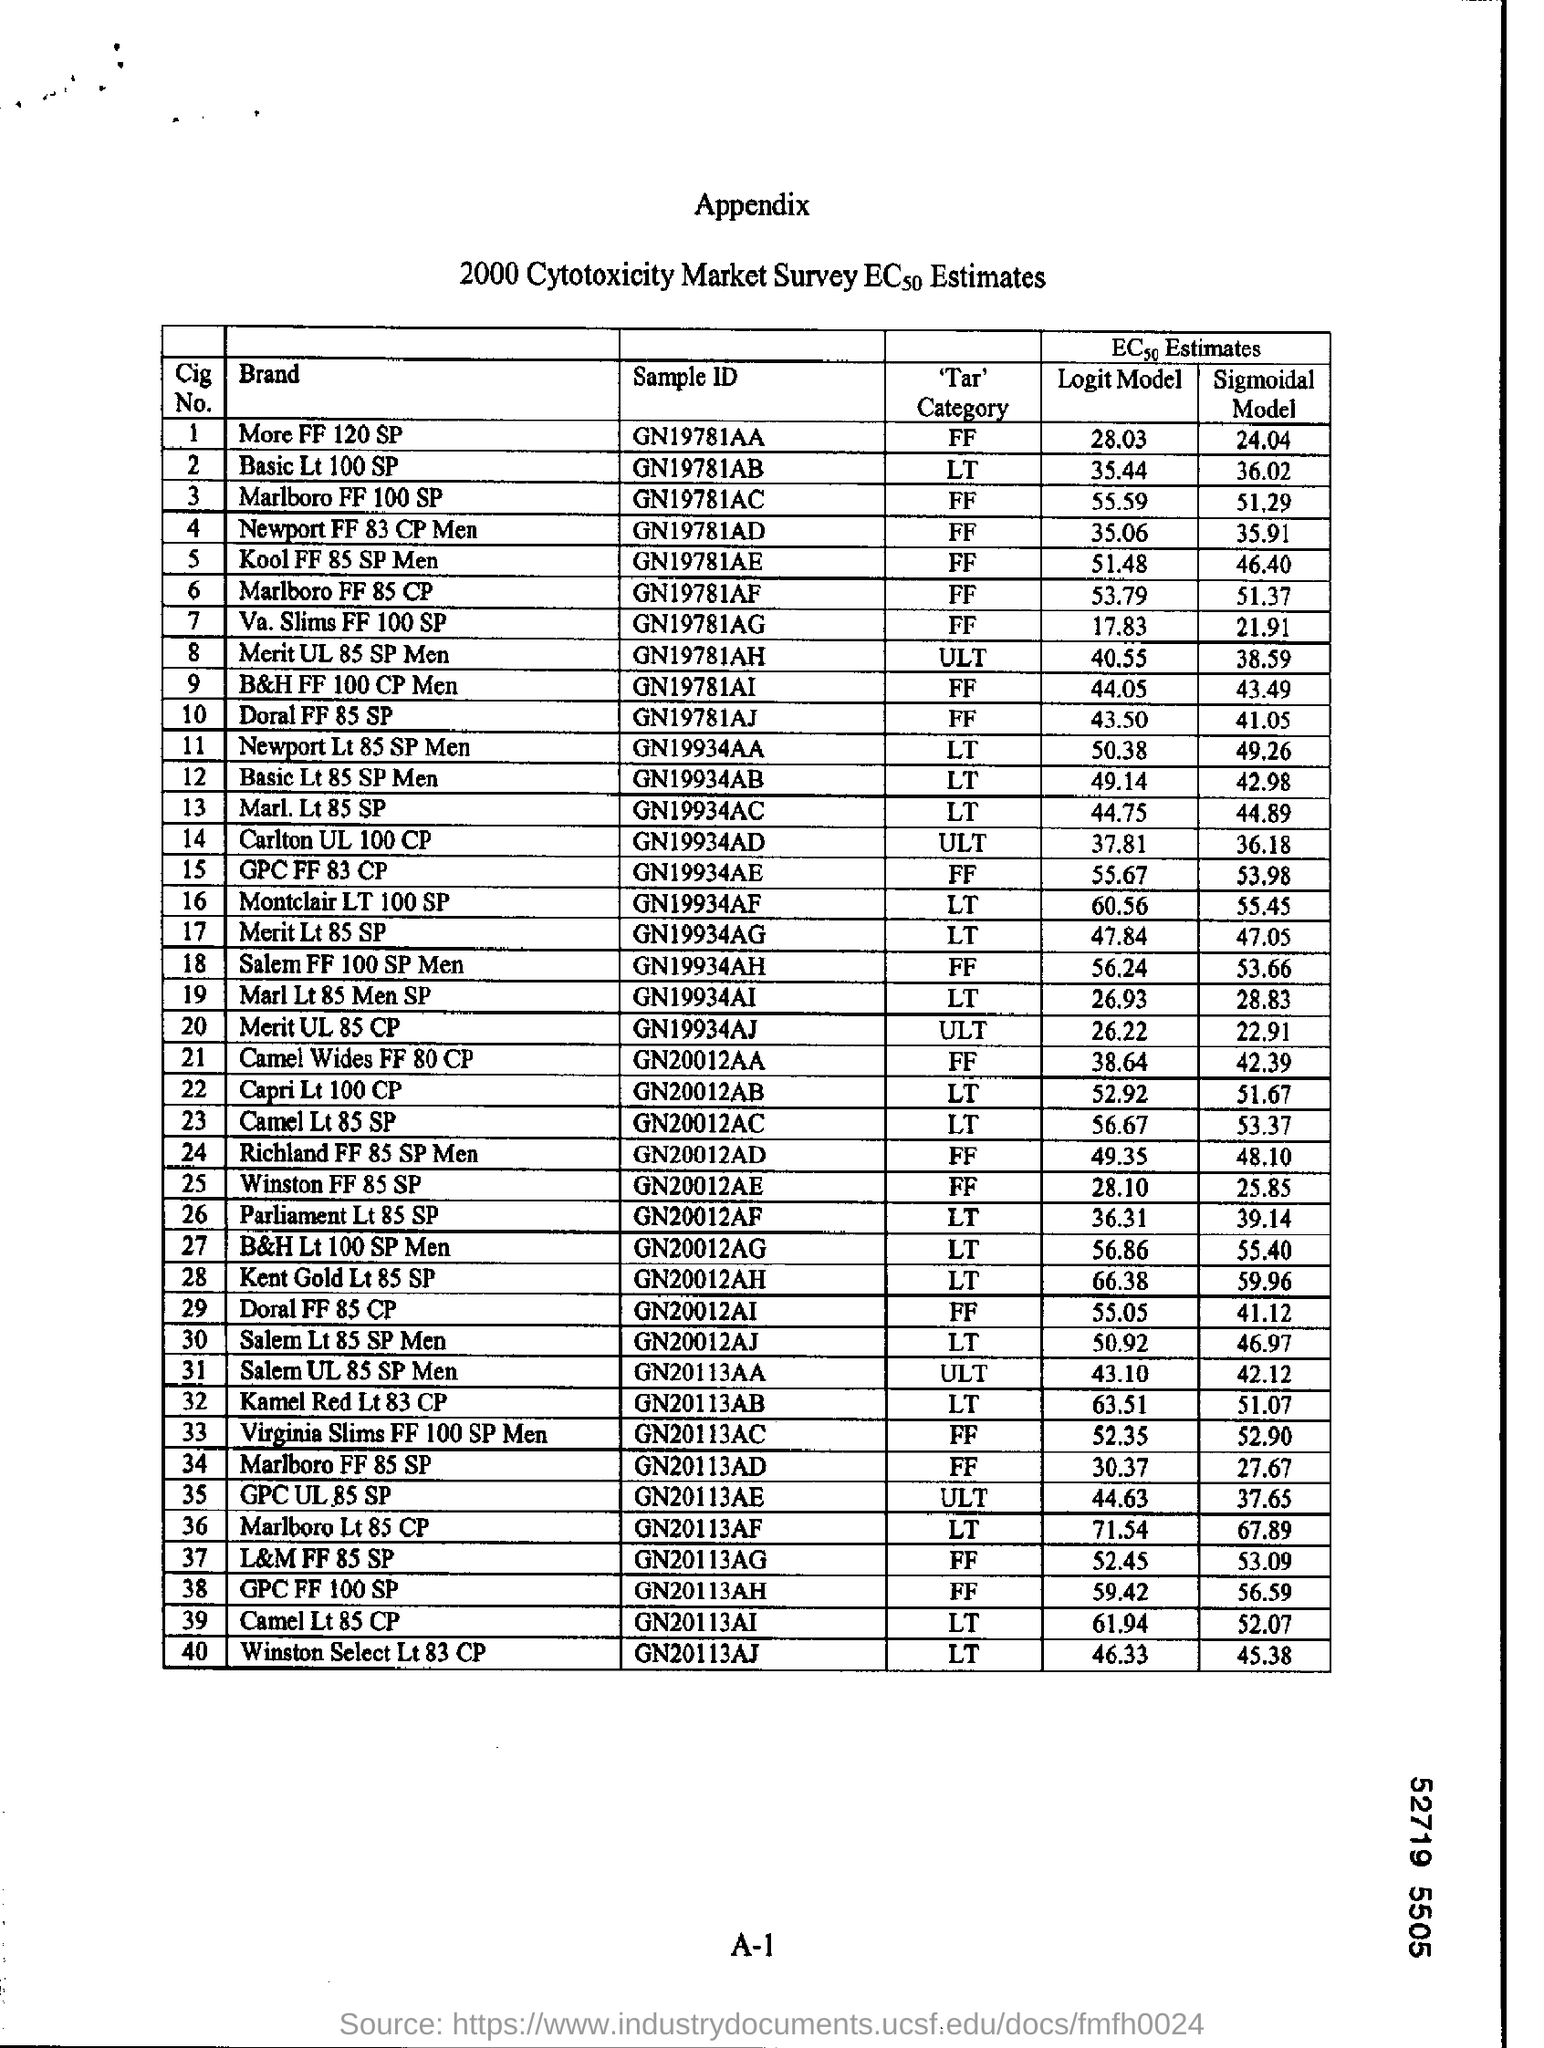Give some essential details in this illustration. What is the sample ID of More FF 120 SP? GN19781AA.. The sample ID of Basic Lt 100 SP is GN19781AB.. 